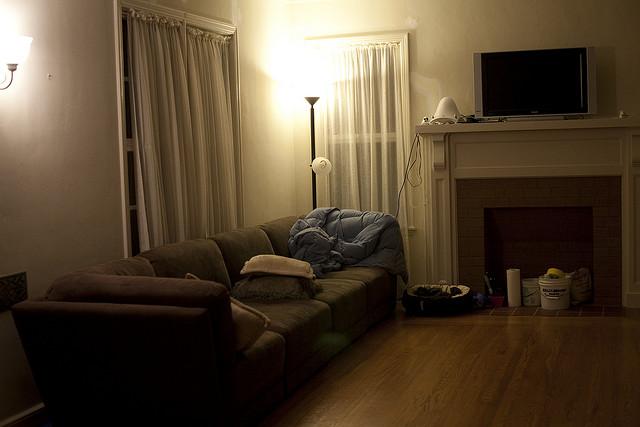Is it night time outside?
Be succinct. Yes. Are the windows open?
Write a very short answer. No. Is there any kitchen in the photo?
Keep it brief. No. What color are the curtains?
Keep it brief. White. Is this a hotel?
Answer briefly. No. Is there a hardwood floor?
Keep it brief. Yes. What is causing the light pattern on the floor?
Give a very brief answer. Lamp. Is the sun shining?
Be succinct. No. Is the sun coming through the window?
Keep it brief. No. Is the television on?
Quick response, please. No. Are the drapes open?
Give a very brief answer. No. What is providing light in the room?
Be succinct. Lamp. Is the lamp on?
Short answer required. Yes. What is in the picture?
Write a very short answer. Living room. How many lamps are in the room?
Short answer required. 2. What room is the mirror in?
Concise answer only. Bathroom. Which room is this?
Be succinct. Living room. Is the room well lit?
Keep it brief. No. Are the blinds open?
Keep it brief. No. What color bricks are around the fireplace?
Short answer required. Red. Are there lights in the room?
Write a very short answer. Yes. Is there a mirror in the room?
Concise answer only. No. They are white?
Short answer required. No. What room is this?
Quick response, please. Living room. Where is the blanket?
Write a very short answer. On couch. 